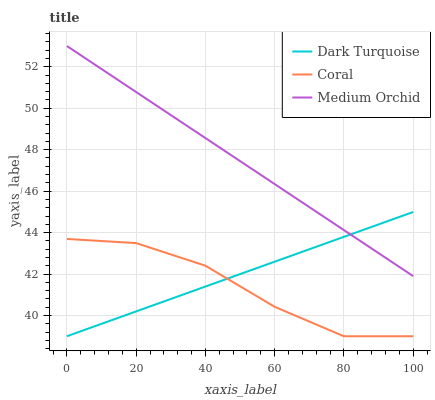Does Coral have the minimum area under the curve?
Answer yes or no. Yes. Does Medium Orchid have the maximum area under the curve?
Answer yes or no. Yes. Does Medium Orchid have the minimum area under the curve?
Answer yes or no. No. Does Coral have the maximum area under the curve?
Answer yes or no. No. Is Dark Turquoise the smoothest?
Answer yes or no. Yes. Is Coral the roughest?
Answer yes or no. Yes. Is Medium Orchid the smoothest?
Answer yes or no. No. Is Medium Orchid the roughest?
Answer yes or no. No. Does Medium Orchid have the lowest value?
Answer yes or no. No. Does Coral have the highest value?
Answer yes or no. No. Is Coral less than Medium Orchid?
Answer yes or no. Yes. Is Medium Orchid greater than Coral?
Answer yes or no. Yes. Does Coral intersect Medium Orchid?
Answer yes or no. No. 